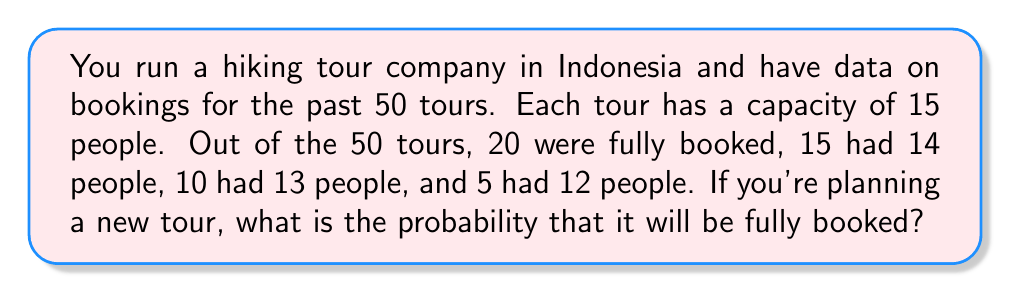Solve this math problem. To solve this problem, we'll use the concept of relative frequency as an estimate of probability. Here's a step-by-step approach:

1. Calculate the total number of tours:
   $N = 20 + 15 + 10 + 5 = 50$ tours

2. Identify the number of fully booked tours:
   $n_{full} = 20$ tours

3. Calculate the probability using the relative frequency formula:
   $$P(\text{fully booked}) = \frac{n_{full}}{N} = \frac{20}{50} = \frac{2}{5} = 0.4$$

4. Convert to a percentage:
   $$0.4 \times 100\% = 40\%$$

Therefore, based on the past data, there is a 40% chance that the new tour will be fully booked.
Answer: 40% 